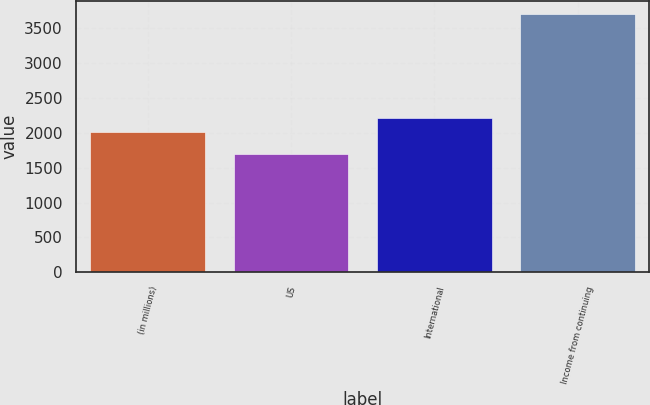<chart> <loc_0><loc_0><loc_500><loc_500><bar_chart><fcel>(in millions)<fcel>US<fcel>International<fcel>Income from continuing<nl><fcel>2014<fcel>1690<fcel>2215.5<fcel>3705<nl></chart> 